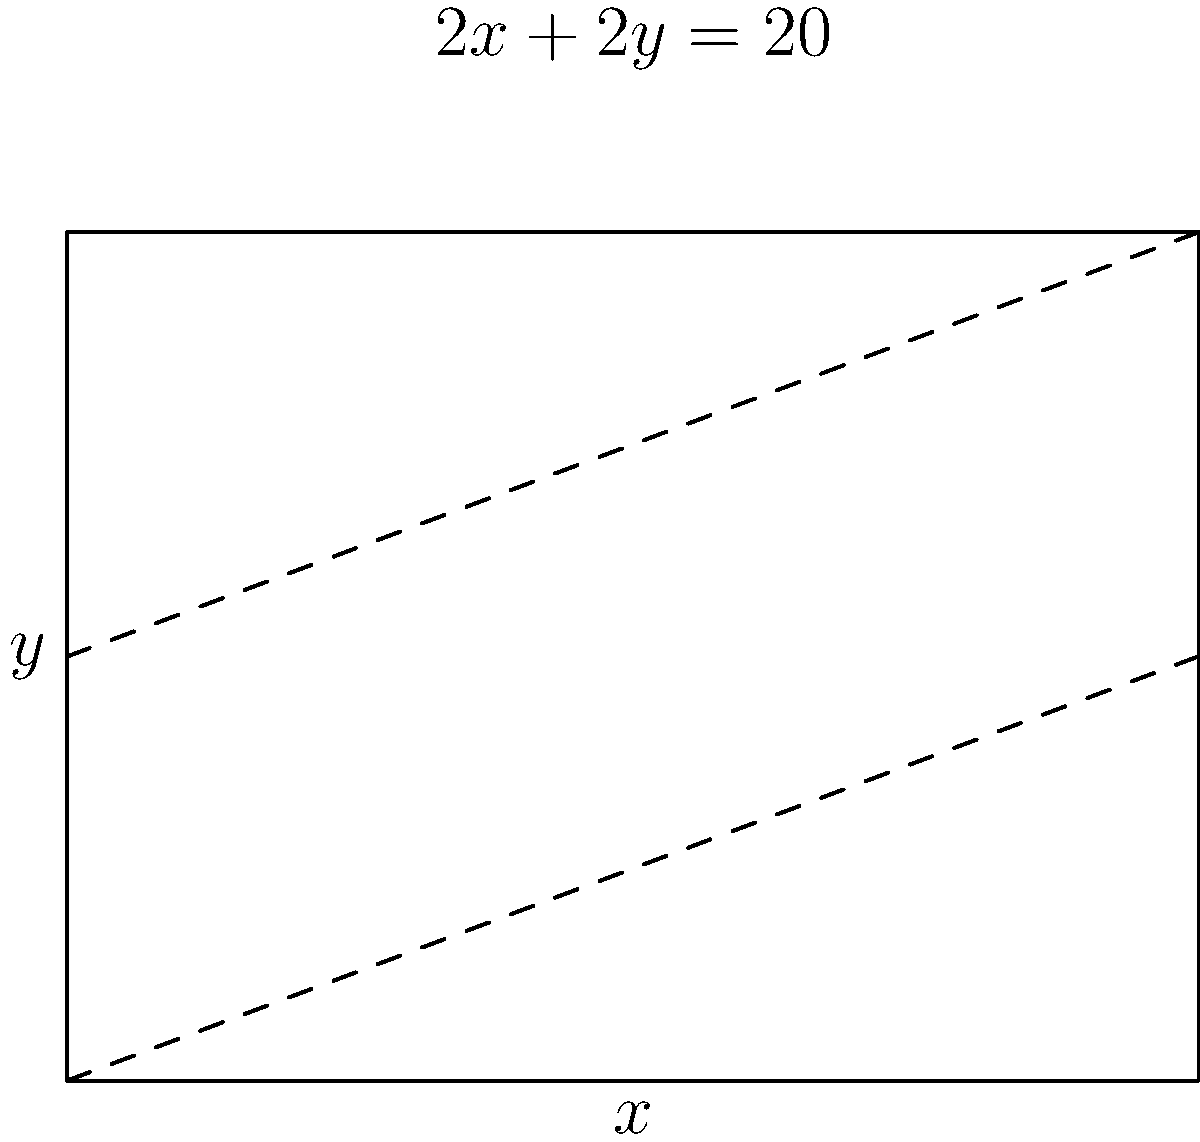A rectangular field is to be enclosed by a fence. The perimeter of the field is fixed at 20 meters. Find the dimensions of the field that will maximize its area. What is the maximum area? Let's approach this step-by-step:

1) Let $x$ be the width and $y$ be the length of the rectangle.

2) Given that the perimeter is 20 meters, we can write:
   $2x + 2y = 20$ or $x + y = 10$

3) We can express $y$ in terms of $x$:
   $y = 10 - x$

4) The area of the rectangle is given by:
   $A = xy = x(10-x) = 10x - x^2$

5) To find the maximum area, we need to find where the derivative of $A$ with respect to $x$ is zero:
   $\frac{dA}{dx} = 10 - 2x$

6) Set this equal to zero and solve:
   $10 - 2x = 0$
   $2x = 10$
   $x = 5$

7) Since $x + y = 10$, when $x = 5$, $y$ must also be 5.

8) To confirm this is a maximum (not a minimum), we can check the second derivative:
   $\frac{d^2A}{dx^2} = -2$, which is negative, confirming a maximum.

9) The maximum area is therefore:
   $A = xy = 5 * 5 = 25$ square meters
Answer: $5$ m $\times$ $5$ m rectangle with area $25$ m² 